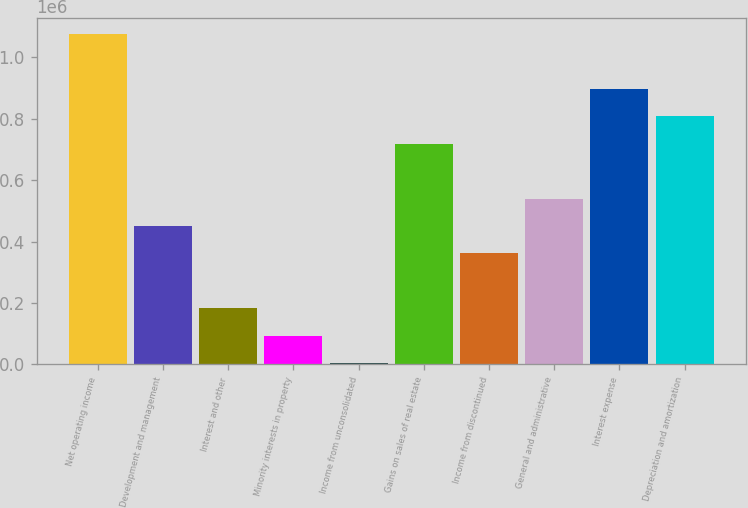<chart> <loc_0><loc_0><loc_500><loc_500><bar_chart><fcel>Net operating income<fcel>Development and management<fcel>Interest and other<fcel>Minority interests in property<fcel>Income from unconsolidated<fcel>Gains on sales of real estate<fcel>Income from discontinued<fcel>General and administrative<fcel>Interest expense<fcel>Depreciation and amortization<nl><fcel>1.07477e+06<fcel>450639<fcel>183153<fcel>93991<fcel>4829<fcel>718125<fcel>361477<fcel>539801<fcel>896449<fcel>807287<nl></chart> 